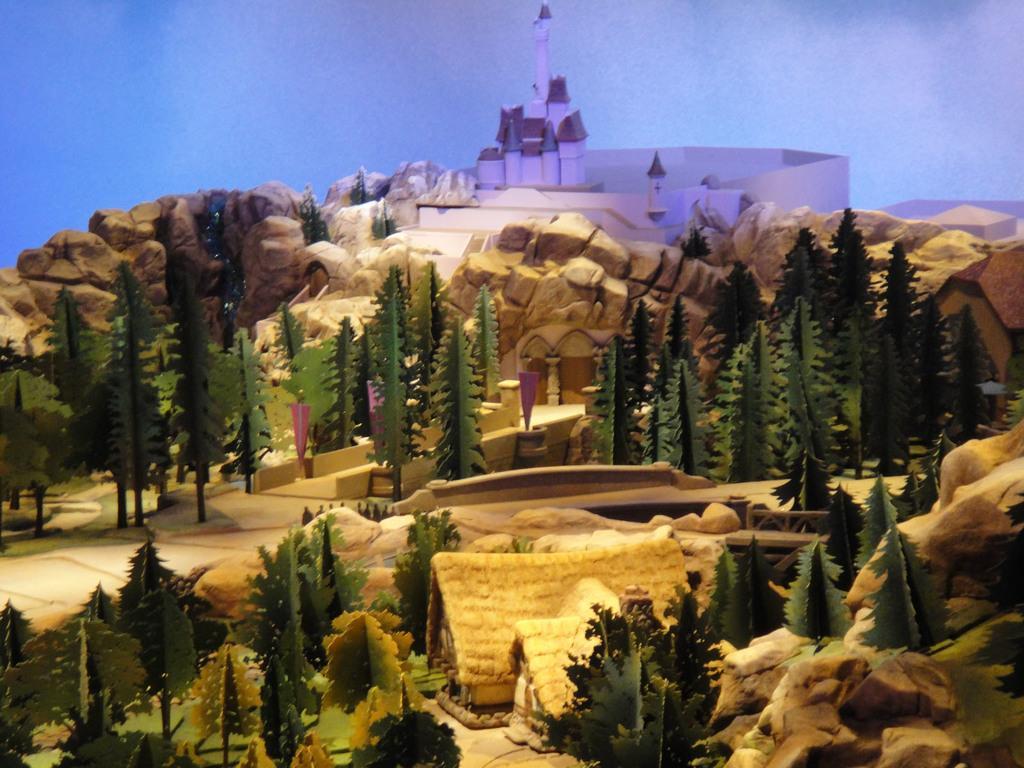In one or two sentences, can you explain what this image depicts? This image looks like a toy. There are trees in the middle. There are huts at the bottom. There is some building at the top. There is sky at the top. 